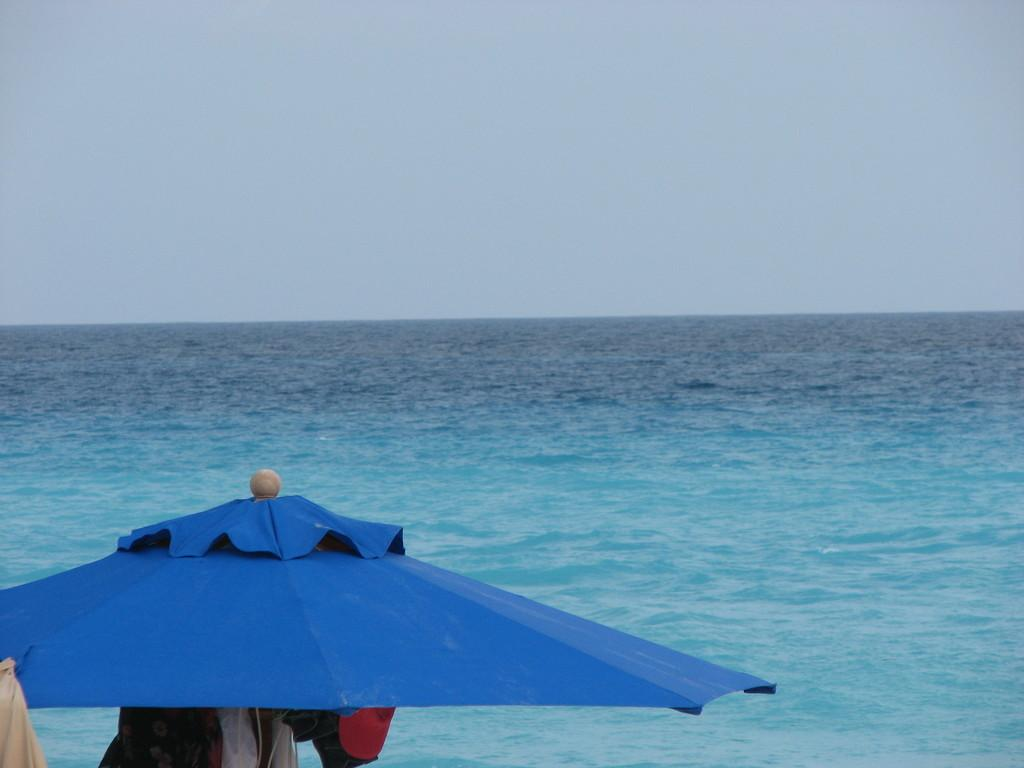What object can be seen on the left side bottom of the image? There is an umbrella on the left side bottom of the image. What else is located on the left side bottom of the image? Clothes are present on the left side bottom of the image. What can be seen in the background of the image? There is water and the sky visible in the background of the image. What type of jar is being used as an ornament in the image? There is no jar present in the image, nor is there any ornament mentioned in the facts. 